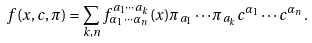Convert formula to latex. <formula><loc_0><loc_0><loc_500><loc_500>f ( x , c , \pi ) = \sum _ { k , n } f _ { \alpha _ { 1 } \cdots \alpha _ { n } } ^ { a _ { 1 } \cdots a _ { k } } ( x ) \pi _ { a _ { 1 } } \cdots \pi _ { a _ { k } } c ^ { \alpha _ { 1 } } \cdots c ^ { \alpha _ { n } } \, .</formula> 